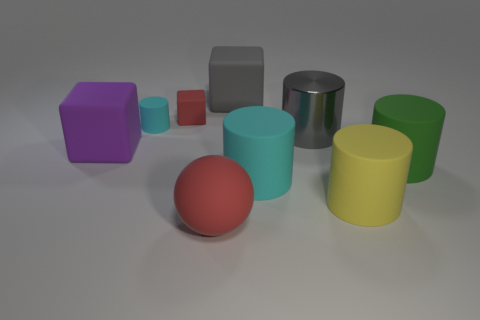Subtract 2 cylinders. How many cylinders are left? 3 Subtract all large yellow rubber cylinders. How many cylinders are left? 4 Subtract all green cylinders. How many cylinders are left? 4 Subtract all green cylinders. Subtract all gray spheres. How many cylinders are left? 4 Add 1 gray blocks. How many objects exist? 10 Subtract all cylinders. How many objects are left? 4 Add 4 tiny rubber things. How many tiny rubber things are left? 6 Add 2 red balls. How many red balls exist? 3 Subtract 0 brown balls. How many objects are left? 9 Subtract all blue metallic cylinders. Subtract all big green rubber cylinders. How many objects are left? 8 